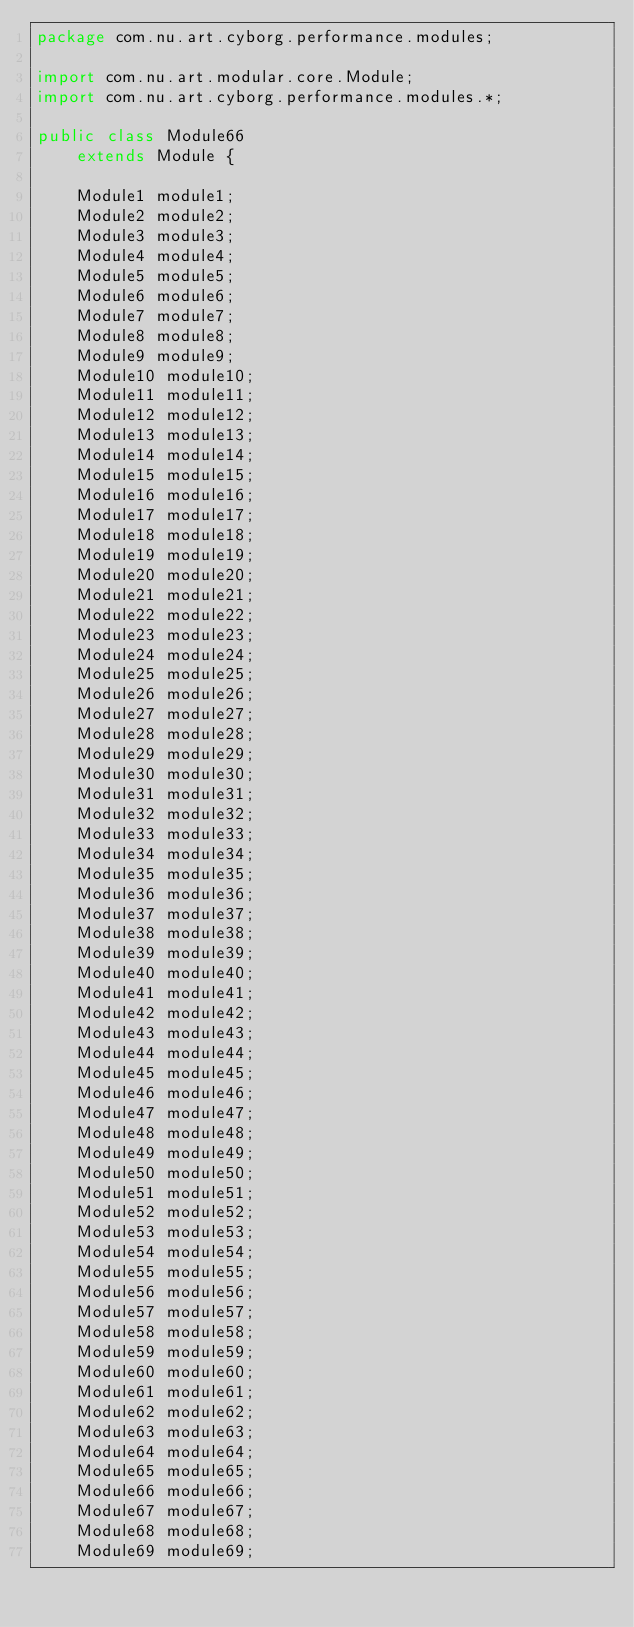<code> <loc_0><loc_0><loc_500><loc_500><_Java_>package com.nu.art.cyborg.performance.modules;

import com.nu.art.modular.core.Module;
import com.nu.art.cyborg.performance.modules.*;

public class Module66
	extends Module {

	Module1 module1;
	Module2 module2;
	Module3 module3;
	Module4 module4;
	Module5 module5;
	Module6 module6;
	Module7 module7;
	Module8 module8;
	Module9 module9;
	Module10 module10;
	Module11 module11;
	Module12 module12;
	Module13 module13;
	Module14 module14;
	Module15 module15;
	Module16 module16;
	Module17 module17;
	Module18 module18;
	Module19 module19;
	Module20 module20;
	Module21 module21;
	Module22 module22;
	Module23 module23;
	Module24 module24;
	Module25 module25;
	Module26 module26;
	Module27 module27;
	Module28 module28;
	Module29 module29;
	Module30 module30;
	Module31 module31;
	Module32 module32;
	Module33 module33;
	Module34 module34;
	Module35 module35;
	Module36 module36;
	Module37 module37;
	Module38 module38;
	Module39 module39;
	Module40 module40;
	Module41 module41;
	Module42 module42;
	Module43 module43;
	Module44 module44;
	Module45 module45;
	Module46 module46;
	Module47 module47;
	Module48 module48;
	Module49 module49;
	Module50 module50;
	Module51 module51;
	Module52 module52;
	Module53 module53;
	Module54 module54;
	Module55 module55;
	Module56 module56;
	Module57 module57;
	Module58 module58;
	Module59 module59;
	Module60 module60;
	Module61 module61;
	Module62 module62;
	Module63 module63;
	Module64 module64;
	Module65 module65;
	Module66 module66;
	Module67 module67;
	Module68 module68;
	Module69 module69;</code> 